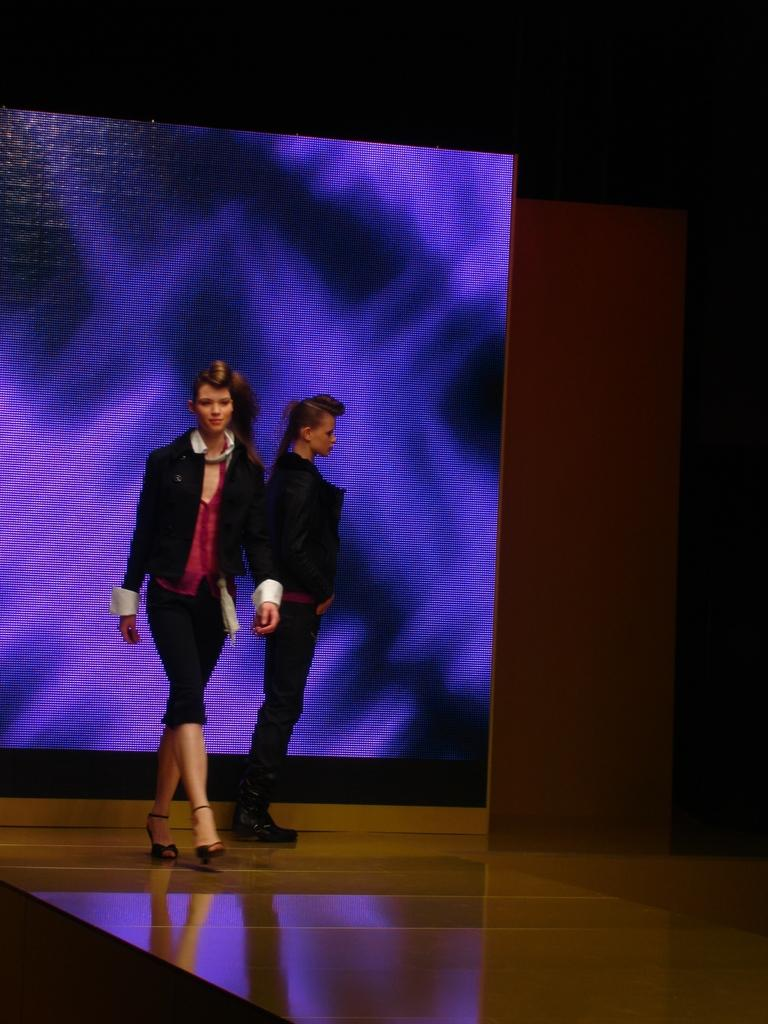What is being displayed on the device in the image? There are two women visible on a display device. What is the background color of the display? The display device shows a blue color background. What are the women wearing in the image? The two women are wearing black dresses. What is the size of the brain visible in the image? There is no brain visible in the image; it features two women on a display device with a blue background. 